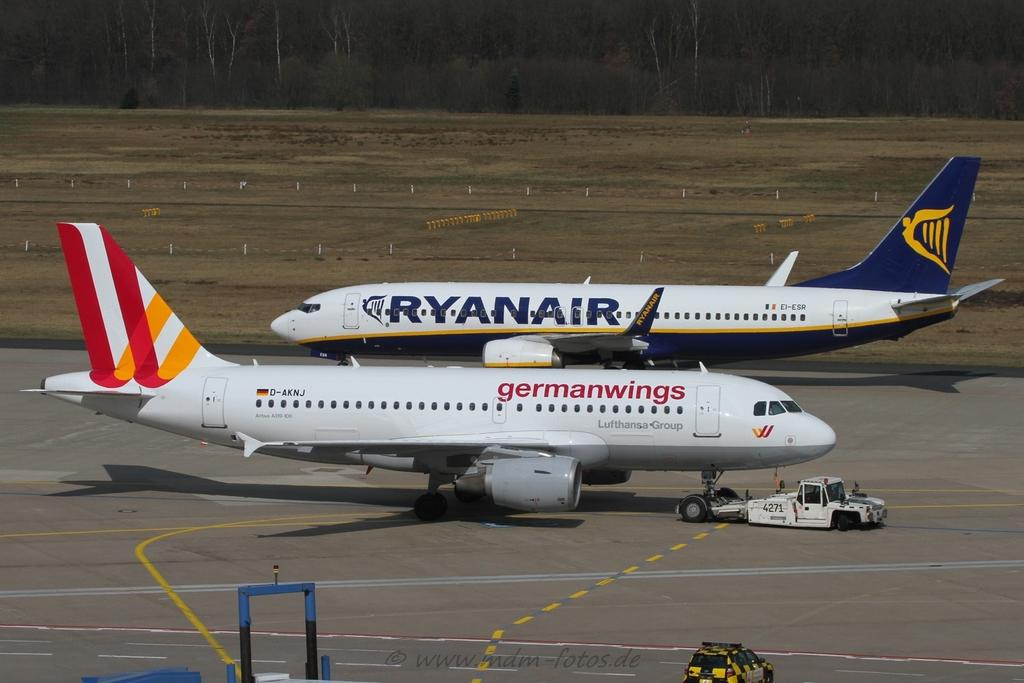Provide a one-sentence caption for the provided image. A German Wings plane sits in front of a Ryanair plane. 